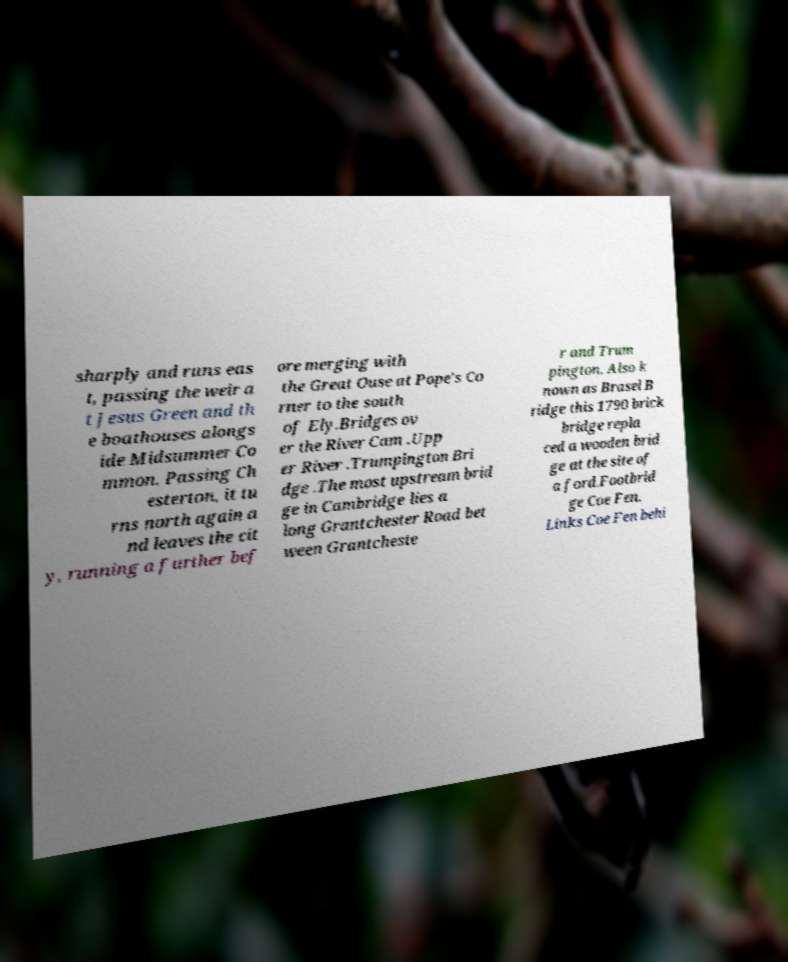Can you read and provide the text displayed in the image?This photo seems to have some interesting text. Can you extract and type it out for me? sharply and runs eas t, passing the weir a t Jesus Green and th e boathouses alongs ide Midsummer Co mmon. Passing Ch esterton, it tu rns north again a nd leaves the cit y, running a further bef ore merging with the Great Ouse at Pope's Co rner to the south of Ely.Bridges ov er the River Cam .Upp er River .Trumpington Bri dge .The most upstream brid ge in Cambridge lies a long Grantchester Road bet ween Grantcheste r and Trum pington. Also k nown as Brasel B ridge this 1790 brick bridge repla ced a wooden brid ge at the site of a ford.Footbrid ge Coe Fen. Links Coe Fen behi 